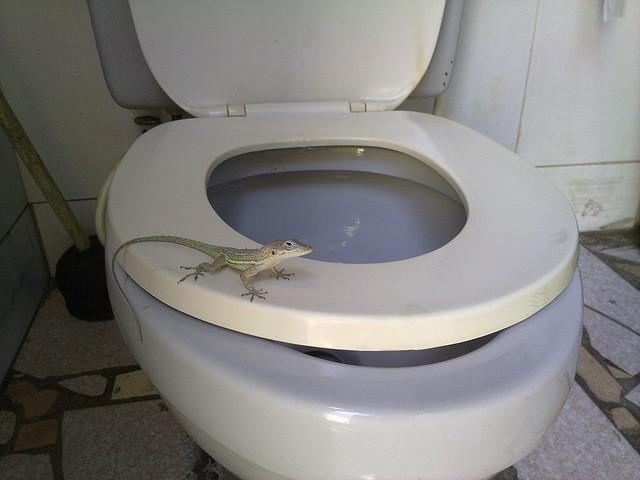How many laptops are on the bed?
Give a very brief answer. 0. 